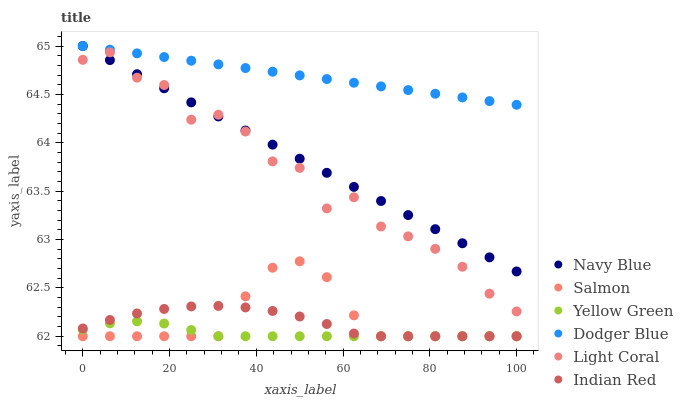Does Yellow Green have the minimum area under the curve?
Answer yes or no. Yes. Does Dodger Blue have the maximum area under the curve?
Answer yes or no. Yes. Does Navy Blue have the minimum area under the curve?
Answer yes or no. No. Does Navy Blue have the maximum area under the curve?
Answer yes or no. No. Is Dodger Blue the smoothest?
Answer yes or no. Yes. Is Light Coral the roughest?
Answer yes or no. Yes. Is Navy Blue the smoothest?
Answer yes or no. No. Is Navy Blue the roughest?
Answer yes or no. No. Does Yellow Green have the lowest value?
Answer yes or no. Yes. Does Navy Blue have the lowest value?
Answer yes or no. No. Does Dodger Blue have the highest value?
Answer yes or no. Yes. Does Salmon have the highest value?
Answer yes or no. No. Is Yellow Green less than Light Coral?
Answer yes or no. Yes. Is Navy Blue greater than Indian Red?
Answer yes or no. Yes. Does Indian Red intersect Salmon?
Answer yes or no. Yes. Is Indian Red less than Salmon?
Answer yes or no. No. Is Indian Red greater than Salmon?
Answer yes or no. No. Does Yellow Green intersect Light Coral?
Answer yes or no. No. 